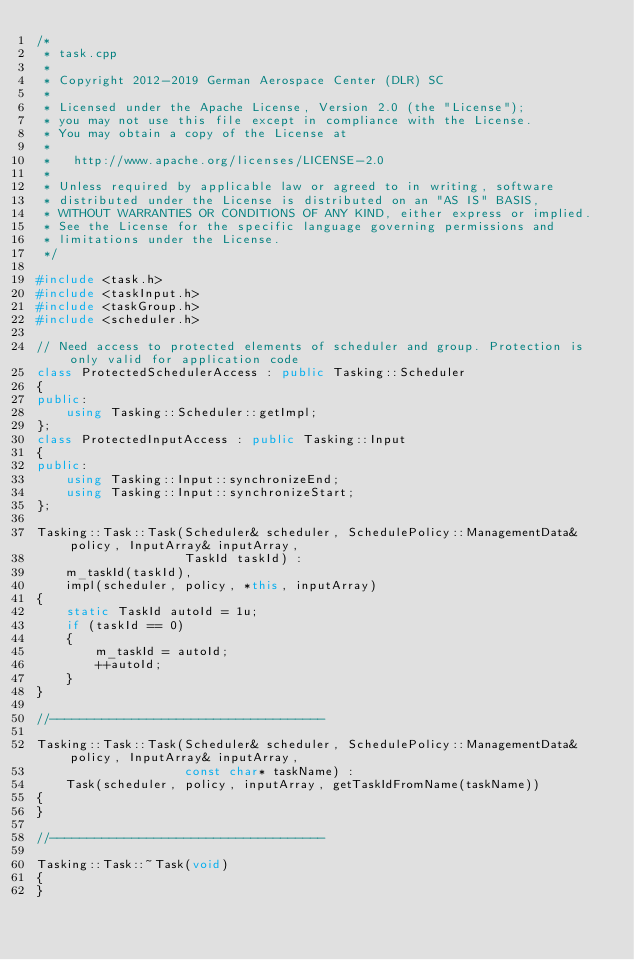Convert code to text. <code><loc_0><loc_0><loc_500><loc_500><_C++_>/*
 * task.cpp
 *
 * Copyright 2012-2019 German Aerospace Center (DLR) SC
 *
 * Licensed under the Apache License, Version 2.0 (the "License");
 * you may not use this file except in compliance with the License.
 * You may obtain a copy of the License at
 *
 *   http://www.apache.org/licenses/LICENSE-2.0
 *
 * Unless required by applicable law or agreed to in writing, software
 * distributed under the License is distributed on an "AS IS" BASIS,
 * WITHOUT WARRANTIES OR CONDITIONS OF ANY KIND, either express or implied.
 * See the License for the specific language governing permissions and
 * limitations under the License.
 */

#include <task.h>
#include <taskInput.h>
#include <taskGroup.h>
#include <scheduler.h>

// Need access to protected elements of scheduler and group. Protection is only valid for application code
class ProtectedSchedulerAccess : public Tasking::Scheduler
{
public:
    using Tasking::Scheduler::getImpl;
};
class ProtectedInputAccess : public Tasking::Input
{
public:
    using Tasking::Input::synchronizeEnd;
    using Tasking::Input::synchronizeStart;
};

Tasking::Task::Task(Scheduler& scheduler, SchedulePolicy::ManagementData& policy, InputArray& inputArray,
                    TaskId taskId) :
    m_taskId(taskId),
    impl(scheduler, policy, *this, inputArray)
{
    static TaskId autoId = 1u;
    if (taskId == 0)
    {
        m_taskId = autoId;
        ++autoId;
    }
}

//-------------------------------------

Tasking::Task::Task(Scheduler& scheduler, SchedulePolicy::ManagementData& policy, InputArray& inputArray,
                    const char* taskName) :
    Task(scheduler, policy, inputArray, getTaskIdFromName(taskName))
{
}

//-------------------------------------

Tasking::Task::~Task(void)
{
}
</code> 